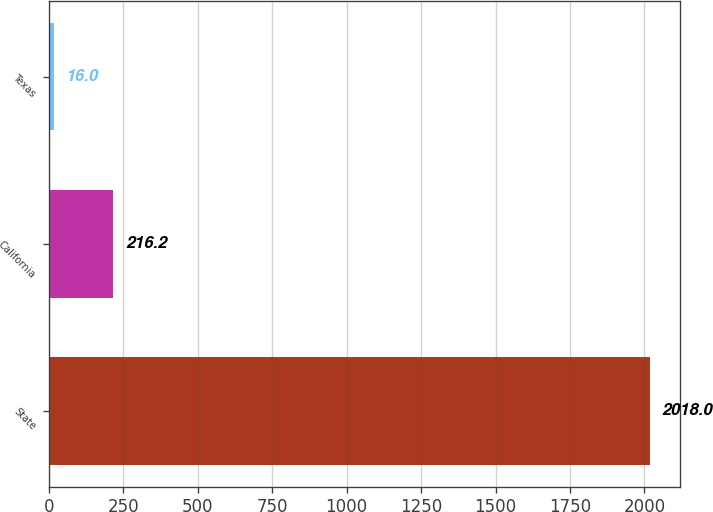<chart> <loc_0><loc_0><loc_500><loc_500><bar_chart><fcel>State<fcel>California<fcel>Texas<nl><fcel>2018<fcel>216.2<fcel>16<nl></chart> 